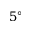<formula> <loc_0><loc_0><loc_500><loc_500>5 ^ { \circ }</formula> 